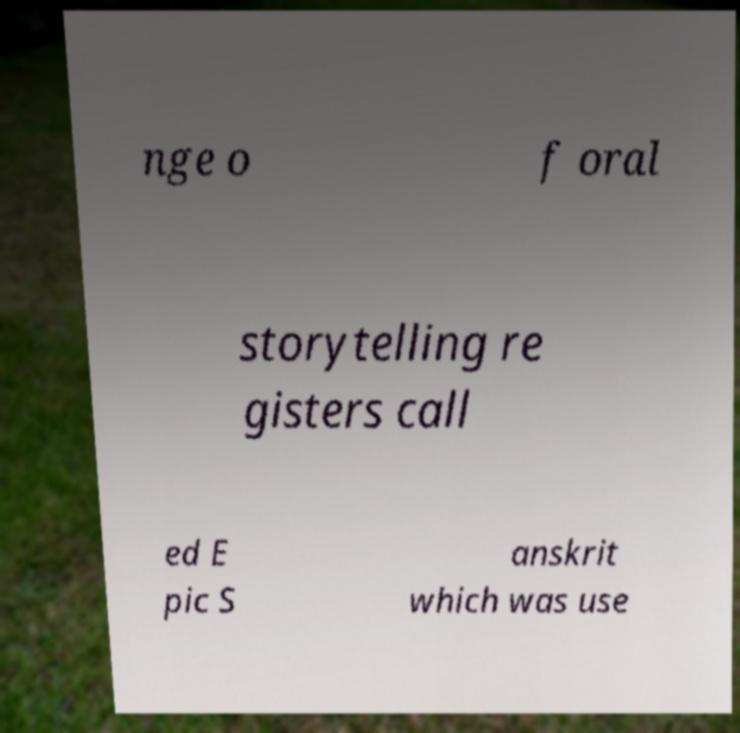Can you read and provide the text displayed in the image?This photo seems to have some interesting text. Can you extract and type it out for me? nge o f oral storytelling re gisters call ed E pic S anskrit which was use 